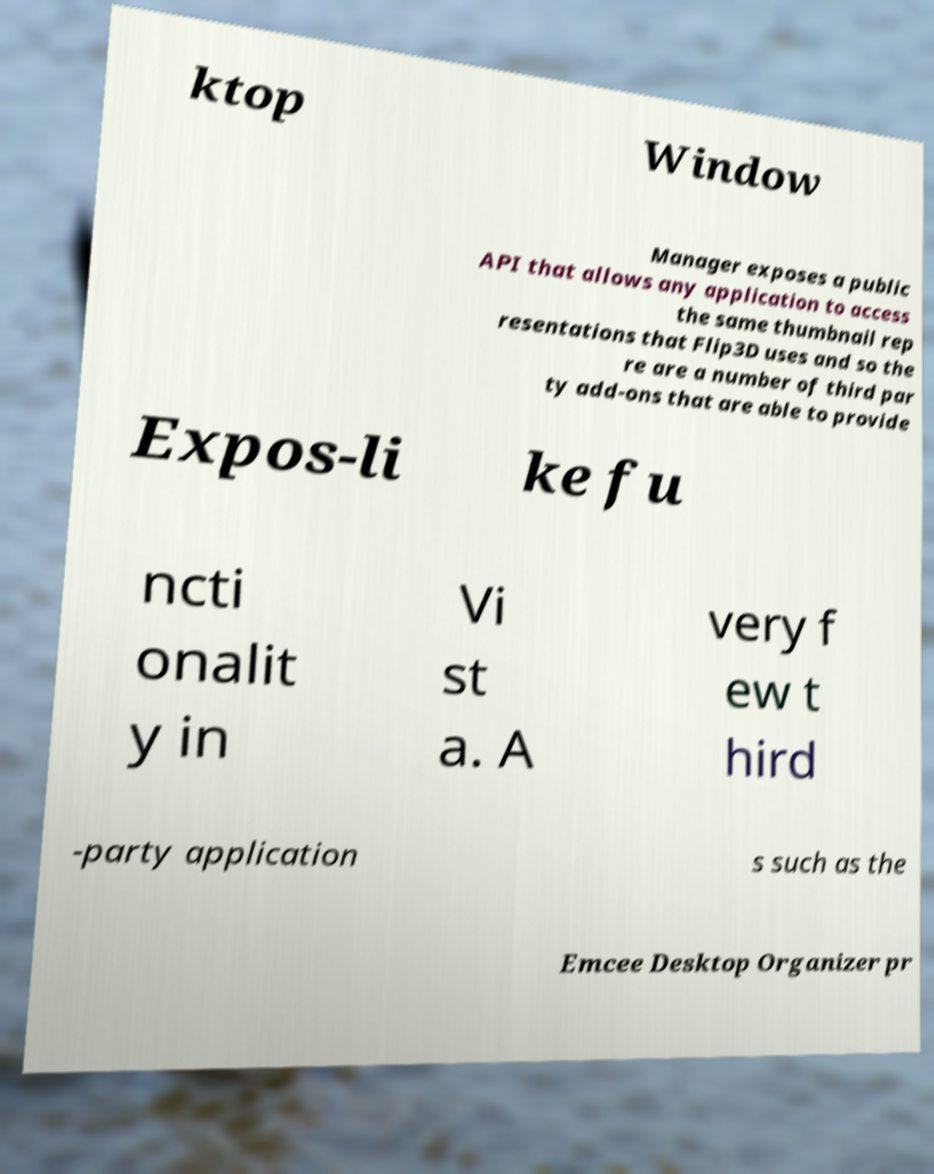Could you extract and type out the text from this image? ktop Window Manager exposes a public API that allows any application to access the same thumbnail rep resentations that Flip3D uses and so the re are a number of third par ty add-ons that are able to provide Expos-li ke fu ncti onalit y in Vi st a. A very f ew t hird -party application s such as the Emcee Desktop Organizer pr 